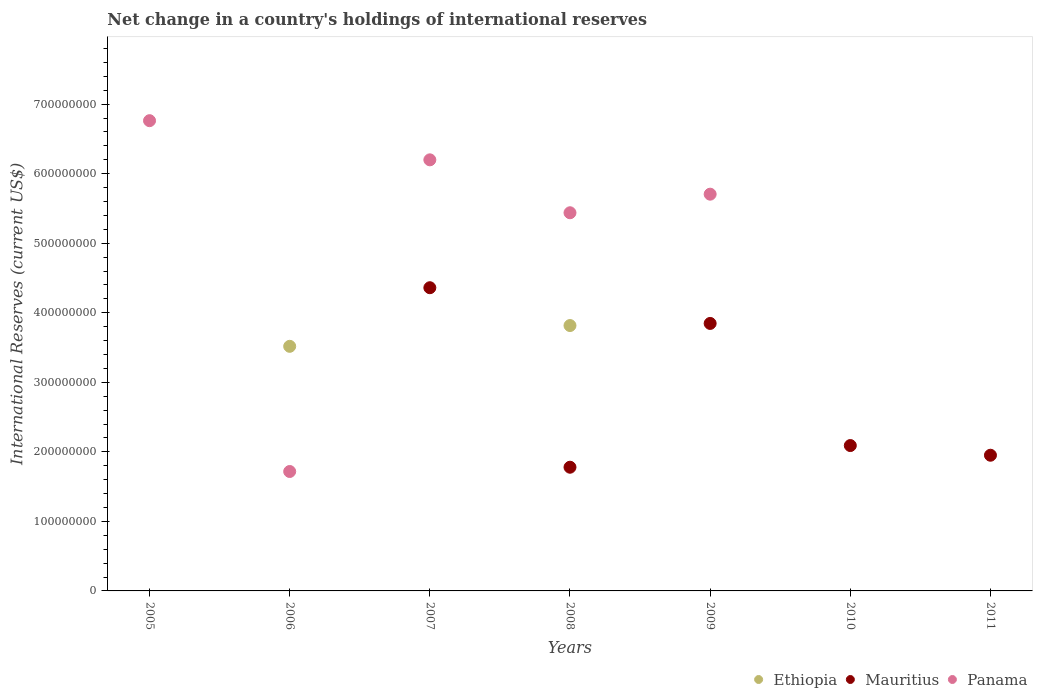What is the international reserves in Mauritius in 2009?
Offer a very short reply. 3.85e+08. Across all years, what is the maximum international reserves in Panama?
Your answer should be compact. 6.76e+08. What is the total international reserves in Panama in the graph?
Ensure brevity in your answer.  2.58e+09. What is the difference between the international reserves in Panama in 2005 and that in 2009?
Provide a short and direct response. 1.06e+08. What is the difference between the international reserves in Panama in 2011 and the international reserves in Ethiopia in 2008?
Your answer should be very brief. -3.82e+08. What is the average international reserves in Panama per year?
Make the answer very short. 3.69e+08. What is the ratio of the international reserves in Mauritius in 2007 to that in 2010?
Provide a short and direct response. 2.09. What is the difference between the highest and the second highest international reserves in Panama?
Provide a short and direct response. 5.63e+07. What is the difference between the highest and the lowest international reserves in Panama?
Your answer should be compact. 6.76e+08. In how many years, is the international reserves in Mauritius greater than the average international reserves in Mauritius taken over all years?
Your answer should be compact. 3. Does the international reserves in Ethiopia monotonically increase over the years?
Give a very brief answer. No. Is the international reserves in Panama strictly greater than the international reserves in Mauritius over the years?
Provide a succinct answer. No. Is the international reserves in Ethiopia strictly less than the international reserves in Panama over the years?
Offer a very short reply. No. How many dotlines are there?
Keep it short and to the point. 3. Does the graph contain any zero values?
Keep it short and to the point. Yes. Does the graph contain grids?
Keep it short and to the point. No. How many legend labels are there?
Offer a terse response. 3. What is the title of the graph?
Give a very brief answer. Net change in a country's holdings of international reserves. Does "Bosnia and Herzegovina" appear as one of the legend labels in the graph?
Your answer should be very brief. No. What is the label or title of the Y-axis?
Ensure brevity in your answer.  International Reserves (current US$). What is the International Reserves (current US$) of Ethiopia in 2005?
Your answer should be very brief. 0. What is the International Reserves (current US$) in Panama in 2005?
Your answer should be compact. 6.76e+08. What is the International Reserves (current US$) of Ethiopia in 2006?
Offer a terse response. 3.52e+08. What is the International Reserves (current US$) in Panama in 2006?
Give a very brief answer. 1.72e+08. What is the International Reserves (current US$) in Ethiopia in 2007?
Ensure brevity in your answer.  0. What is the International Reserves (current US$) in Mauritius in 2007?
Provide a short and direct response. 4.36e+08. What is the International Reserves (current US$) of Panama in 2007?
Offer a very short reply. 6.20e+08. What is the International Reserves (current US$) of Ethiopia in 2008?
Ensure brevity in your answer.  3.82e+08. What is the International Reserves (current US$) in Mauritius in 2008?
Offer a very short reply. 1.78e+08. What is the International Reserves (current US$) in Panama in 2008?
Offer a very short reply. 5.44e+08. What is the International Reserves (current US$) of Ethiopia in 2009?
Provide a succinct answer. 0. What is the International Reserves (current US$) in Mauritius in 2009?
Offer a very short reply. 3.85e+08. What is the International Reserves (current US$) in Panama in 2009?
Provide a succinct answer. 5.71e+08. What is the International Reserves (current US$) in Mauritius in 2010?
Ensure brevity in your answer.  2.09e+08. What is the International Reserves (current US$) of Panama in 2010?
Make the answer very short. 0. What is the International Reserves (current US$) in Mauritius in 2011?
Provide a succinct answer. 1.95e+08. What is the International Reserves (current US$) of Panama in 2011?
Provide a succinct answer. 0. Across all years, what is the maximum International Reserves (current US$) of Ethiopia?
Ensure brevity in your answer.  3.82e+08. Across all years, what is the maximum International Reserves (current US$) in Mauritius?
Provide a short and direct response. 4.36e+08. Across all years, what is the maximum International Reserves (current US$) in Panama?
Make the answer very short. 6.76e+08. Across all years, what is the minimum International Reserves (current US$) of Ethiopia?
Provide a succinct answer. 0. Across all years, what is the minimum International Reserves (current US$) of Panama?
Your answer should be very brief. 0. What is the total International Reserves (current US$) of Ethiopia in the graph?
Keep it short and to the point. 7.33e+08. What is the total International Reserves (current US$) in Mauritius in the graph?
Your response must be concise. 1.40e+09. What is the total International Reserves (current US$) of Panama in the graph?
Offer a terse response. 2.58e+09. What is the difference between the International Reserves (current US$) of Panama in 2005 and that in 2006?
Ensure brevity in your answer.  5.04e+08. What is the difference between the International Reserves (current US$) of Panama in 2005 and that in 2007?
Your answer should be compact. 5.63e+07. What is the difference between the International Reserves (current US$) in Panama in 2005 and that in 2008?
Your answer should be very brief. 1.32e+08. What is the difference between the International Reserves (current US$) of Panama in 2005 and that in 2009?
Offer a terse response. 1.06e+08. What is the difference between the International Reserves (current US$) in Panama in 2006 and that in 2007?
Keep it short and to the point. -4.48e+08. What is the difference between the International Reserves (current US$) of Ethiopia in 2006 and that in 2008?
Your answer should be very brief. -2.99e+07. What is the difference between the International Reserves (current US$) of Panama in 2006 and that in 2008?
Ensure brevity in your answer.  -3.72e+08. What is the difference between the International Reserves (current US$) in Panama in 2006 and that in 2009?
Your answer should be very brief. -3.99e+08. What is the difference between the International Reserves (current US$) in Mauritius in 2007 and that in 2008?
Give a very brief answer. 2.58e+08. What is the difference between the International Reserves (current US$) of Panama in 2007 and that in 2008?
Your answer should be very brief. 7.61e+07. What is the difference between the International Reserves (current US$) of Mauritius in 2007 and that in 2009?
Offer a very short reply. 5.14e+07. What is the difference between the International Reserves (current US$) of Panama in 2007 and that in 2009?
Give a very brief answer. 4.94e+07. What is the difference between the International Reserves (current US$) of Mauritius in 2007 and that in 2010?
Your answer should be compact. 2.27e+08. What is the difference between the International Reserves (current US$) in Mauritius in 2007 and that in 2011?
Keep it short and to the point. 2.41e+08. What is the difference between the International Reserves (current US$) of Mauritius in 2008 and that in 2009?
Provide a succinct answer. -2.07e+08. What is the difference between the International Reserves (current US$) of Panama in 2008 and that in 2009?
Your answer should be very brief. -2.67e+07. What is the difference between the International Reserves (current US$) of Mauritius in 2008 and that in 2010?
Keep it short and to the point. -3.12e+07. What is the difference between the International Reserves (current US$) in Mauritius in 2008 and that in 2011?
Your response must be concise. -1.72e+07. What is the difference between the International Reserves (current US$) in Mauritius in 2009 and that in 2010?
Ensure brevity in your answer.  1.76e+08. What is the difference between the International Reserves (current US$) of Mauritius in 2009 and that in 2011?
Your response must be concise. 1.90e+08. What is the difference between the International Reserves (current US$) of Mauritius in 2010 and that in 2011?
Provide a succinct answer. 1.39e+07. What is the difference between the International Reserves (current US$) in Ethiopia in 2006 and the International Reserves (current US$) in Mauritius in 2007?
Offer a terse response. -8.43e+07. What is the difference between the International Reserves (current US$) in Ethiopia in 2006 and the International Reserves (current US$) in Panama in 2007?
Your response must be concise. -2.68e+08. What is the difference between the International Reserves (current US$) in Ethiopia in 2006 and the International Reserves (current US$) in Mauritius in 2008?
Ensure brevity in your answer.  1.74e+08. What is the difference between the International Reserves (current US$) of Ethiopia in 2006 and the International Reserves (current US$) of Panama in 2008?
Provide a short and direct response. -1.92e+08. What is the difference between the International Reserves (current US$) in Ethiopia in 2006 and the International Reserves (current US$) in Mauritius in 2009?
Offer a terse response. -3.29e+07. What is the difference between the International Reserves (current US$) of Ethiopia in 2006 and the International Reserves (current US$) of Panama in 2009?
Your response must be concise. -2.19e+08. What is the difference between the International Reserves (current US$) in Ethiopia in 2006 and the International Reserves (current US$) in Mauritius in 2010?
Make the answer very short. 1.43e+08. What is the difference between the International Reserves (current US$) in Ethiopia in 2006 and the International Reserves (current US$) in Mauritius in 2011?
Provide a short and direct response. 1.57e+08. What is the difference between the International Reserves (current US$) in Mauritius in 2007 and the International Reserves (current US$) in Panama in 2008?
Your response must be concise. -1.08e+08. What is the difference between the International Reserves (current US$) in Mauritius in 2007 and the International Reserves (current US$) in Panama in 2009?
Provide a succinct answer. -1.35e+08. What is the difference between the International Reserves (current US$) in Ethiopia in 2008 and the International Reserves (current US$) in Mauritius in 2009?
Provide a short and direct response. -3.03e+06. What is the difference between the International Reserves (current US$) of Ethiopia in 2008 and the International Reserves (current US$) of Panama in 2009?
Make the answer very short. -1.89e+08. What is the difference between the International Reserves (current US$) in Mauritius in 2008 and the International Reserves (current US$) in Panama in 2009?
Ensure brevity in your answer.  -3.93e+08. What is the difference between the International Reserves (current US$) of Ethiopia in 2008 and the International Reserves (current US$) of Mauritius in 2010?
Offer a very short reply. 1.73e+08. What is the difference between the International Reserves (current US$) in Ethiopia in 2008 and the International Reserves (current US$) in Mauritius in 2011?
Offer a terse response. 1.86e+08. What is the average International Reserves (current US$) in Ethiopia per year?
Offer a terse response. 1.05e+08. What is the average International Reserves (current US$) in Mauritius per year?
Your answer should be very brief. 2.00e+08. What is the average International Reserves (current US$) of Panama per year?
Keep it short and to the point. 3.69e+08. In the year 2006, what is the difference between the International Reserves (current US$) in Ethiopia and International Reserves (current US$) in Panama?
Give a very brief answer. 1.80e+08. In the year 2007, what is the difference between the International Reserves (current US$) of Mauritius and International Reserves (current US$) of Panama?
Ensure brevity in your answer.  -1.84e+08. In the year 2008, what is the difference between the International Reserves (current US$) in Ethiopia and International Reserves (current US$) in Mauritius?
Your response must be concise. 2.04e+08. In the year 2008, what is the difference between the International Reserves (current US$) in Ethiopia and International Reserves (current US$) in Panama?
Provide a succinct answer. -1.62e+08. In the year 2008, what is the difference between the International Reserves (current US$) in Mauritius and International Reserves (current US$) in Panama?
Your answer should be very brief. -3.66e+08. In the year 2009, what is the difference between the International Reserves (current US$) of Mauritius and International Reserves (current US$) of Panama?
Keep it short and to the point. -1.86e+08. What is the ratio of the International Reserves (current US$) of Panama in 2005 to that in 2006?
Your response must be concise. 3.94. What is the ratio of the International Reserves (current US$) in Panama in 2005 to that in 2007?
Ensure brevity in your answer.  1.09. What is the ratio of the International Reserves (current US$) in Panama in 2005 to that in 2008?
Offer a very short reply. 1.24. What is the ratio of the International Reserves (current US$) in Panama in 2005 to that in 2009?
Provide a short and direct response. 1.19. What is the ratio of the International Reserves (current US$) in Panama in 2006 to that in 2007?
Give a very brief answer. 0.28. What is the ratio of the International Reserves (current US$) of Ethiopia in 2006 to that in 2008?
Make the answer very short. 0.92. What is the ratio of the International Reserves (current US$) in Panama in 2006 to that in 2008?
Offer a very short reply. 0.32. What is the ratio of the International Reserves (current US$) of Panama in 2006 to that in 2009?
Ensure brevity in your answer.  0.3. What is the ratio of the International Reserves (current US$) of Mauritius in 2007 to that in 2008?
Your answer should be very brief. 2.45. What is the ratio of the International Reserves (current US$) in Panama in 2007 to that in 2008?
Offer a very short reply. 1.14. What is the ratio of the International Reserves (current US$) of Mauritius in 2007 to that in 2009?
Provide a short and direct response. 1.13. What is the ratio of the International Reserves (current US$) of Panama in 2007 to that in 2009?
Give a very brief answer. 1.09. What is the ratio of the International Reserves (current US$) in Mauritius in 2007 to that in 2010?
Give a very brief answer. 2.09. What is the ratio of the International Reserves (current US$) in Mauritius in 2007 to that in 2011?
Your response must be concise. 2.23. What is the ratio of the International Reserves (current US$) in Mauritius in 2008 to that in 2009?
Make the answer very short. 0.46. What is the ratio of the International Reserves (current US$) in Panama in 2008 to that in 2009?
Give a very brief answer. 0.95. What is the ratio of the International Reserves (current US$) in Mauritius in 2008 to that in 2010?
Ensure brevity in your answer.  0.85. What is the ratio of the International Reserves (current US$) of Mauritius in 2008 to that in 2011?
Your answer should be very brief. 0.91. What is the ratio of the International Reserves (current US$) in Mauritius in 2009 to that in 2010?
Offer a very short reply. 1.84. What is the ratio of the International Reserves (current US$) in Mauritius in 2009 to that in 2011?
Offer a very short reply. 1.97. What is the ratio of the International Reserves (current US$) of Mauritius in 2010 to that in 2011?
Provide a succinct answer. 1.07. What is the difference between the highest and the second highest International Reserves (current US$) in Mauritius?
Give a very brief answer. 5.14e+07. What is the difference between the highest and the second highest International Reserves (current US$) of Panama?
Your answer should be very brief. 5.63e+07. What is the difference between the highest and the lowest International Reserves (current US$) in Ethiopia?
Your answer should be very brief. 3.82e+08. What is the difference between the highest and the lowest International Reserves (current US$) of Mauritius?
Provide a succinct answer. 4.36e+08. What is the difference between the highest and the lowest International Reserves (current US$) of Panama?
Your answer should be compact. 6.76e+08. 